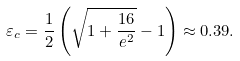Convert formula to latex. <formula><loc_0><loc_0><loc_500><loc_500>\varepsilon _ { c } = \frac { 1 } { 2 } \left ( \sqrt { 1 + \frac { 1 6 } { e ^ { 2 } } } - 1 \right ) \approx 0 . 3 9 .</formula> 